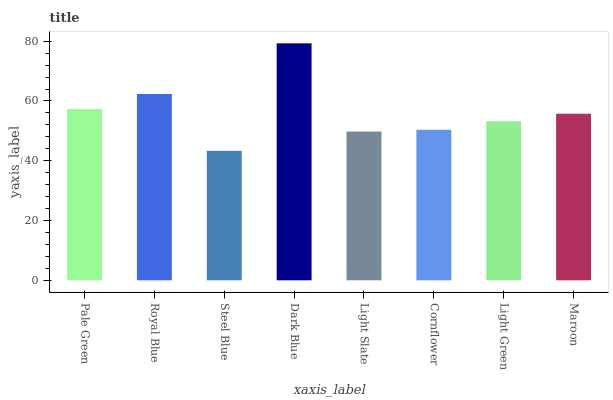Is Steel Blue the minimum?
Answer yes or no. Yes. Is Dark Blue the maximum?
Answer yes or no. Yes. Is Royal Blue the minimum?
Answer yes or no. No. Is Royal Blue the maximum?
Answer yes or no. No. Is Royal Blue greater than Pale Green?
Answer yes or no. Yes. Is Pale Green less than Royal Blue?
Answer yes or no. Yes. Is Pale Green greater than Royal Blue?
Answer yes or no. No. Is Royal Blue less than Pale Green?
Answer yes or no. No. Is Maroon the high median?
Answer yes or no. Yes. Is Light Green the low median?
Answer yes or no. Yes. Is Pale Green the high median?
Answer yes or no. No. Is Steel Blue the low median?
Answer yes or no. No. 